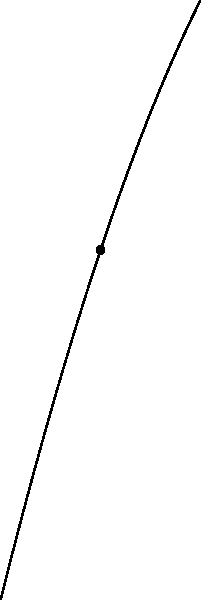In our village football tournament, a player kicks the ball, and its trajectory follows the parabola $y=-0.1x^2+4x$, where $x$ and $y$ are measured in meters. Find the equation of the tangent line to this parabola at the point $(5,15)$, which represents the ball's position when it's directly above the center of our ceremonial grounds. To find the equation of the tangent line, we need to follow these steps:

1) The general equation of a line is $y = mx + b$, where $m$ is the slope and $b$ is the y-intercept.

2) To find the slope $m$, we need to differentiate the function $y=-0.1x^2+4x$:
   $\frac{dy}{dx} = -0.2x + 4$

3) At the point $(5,15)$, the slope is:
   $m = -0.2(5) + 4 = -1 + 4 = 3$

4) Now we have the point $(5,15)$ and the slope $3$. We can use the point-slope form of a line:
   $y - y_1 = m(x - x_1)$
   $y - 15 = 3(x - 5)$

5) Simplify:
   $y = 3x - 15 + 15$
   $y = 3x$

Therefore, the equation of the tangent line is $y = 3x$.
Answer: $y = 3x$ 